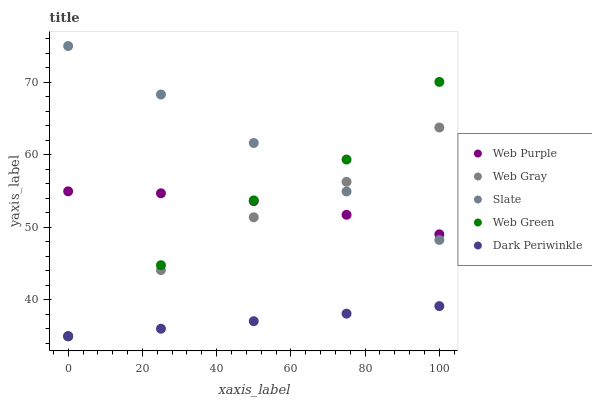Does Dark Periwinkle have the minimum area under the curve?
Answer yes or no. Yes. Does Slate have the maximum area under the curve?
Answer yes or no. Yes. Does Web Gray have the minimum area under the curve?
Answer yes or no. No. Does Web Gray have the maximum area under the curve?
Answer yes or no. No. Is Slate the smoothest?
Answer yes or no. Yes. Is Web Green the roughest?
Answer yes or no. Yes. Is Web Gray the smoothest?
Answer yes or no. No. Is Web Gray the roughest?
Answer yes or no. No. Does Web Gray have the lowest value?
Answer yes or no. Yes. Does Slate have the lowest value?
Answer yes or no. No. Does Slate have the highest value?
Answer yes or no. Yes. Does Web Gray have the highest value?
Answer yes or no. No. Is Dark Periwinkle less than Web Purple?
Answer yes or no. Yes. Is Slate greater than Dark Periwinkle?
Answer yes or no. Yes. Does Slate intersect Web Purple?
Answer yes or no. Yes. Is Slate less than Web Purple?
Answer yes or no. No. Is Slate greater than Web Purple?
Answer yes or no. No. Does Dark Periwinkle intersect Web Purple?
Answer yes or no. No. 